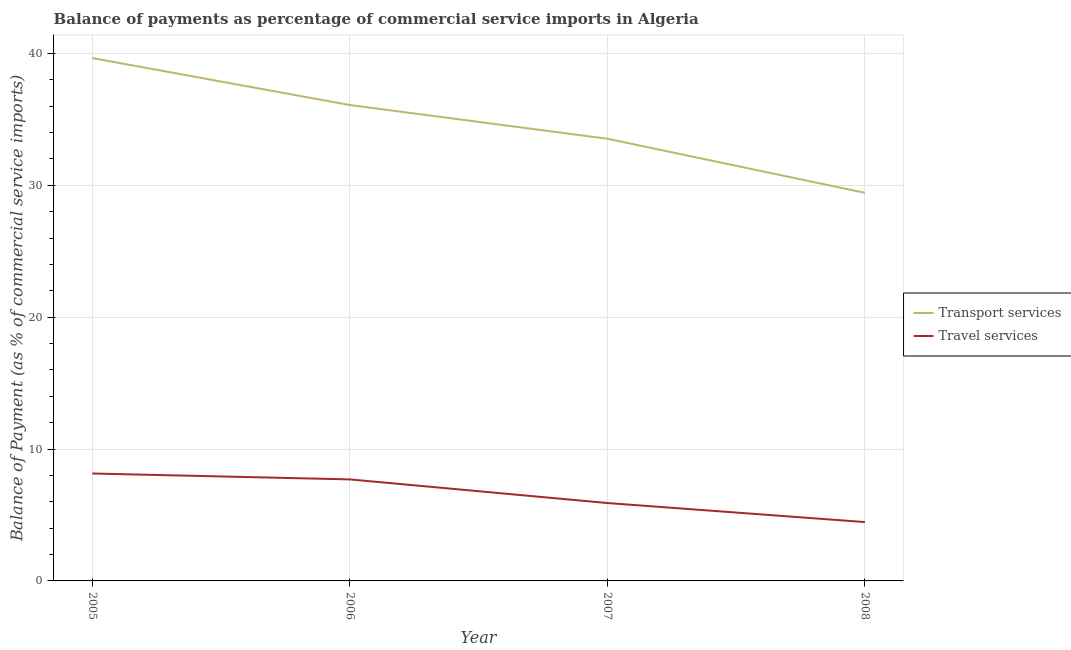Does the line corresponding to balance of payments of travel services intersect with the line corresponding to balance of payments of transport services?
Your response must be concise. No. What is the balance of payments of transport services in 2007?
Make the answer very short. 33.53. Across all years, what is the maximum balance of payments of transport services?
Provide a succinct answer. 39.65. Across all years, what is the minimum balance of payments of transport services?
Keep it short and to the point. 29.43. What is the total balance of payments of travel services in the graph?
Provide a short and direct response. 26.22. What is the difference between the balance of payments of transport services in 2005 and that in 2007?
Your answer should be compact. 6.12. What is the difference between the balance of payments of transport services in 2007 and the balance of payments of travel services in 2008?
Make the answer very short. 29.07. What is the average balance of payments of transport services per year?
Your answer should be very brief. 34.68. In the year 2008, what is the difference between the balance of payments of transport services and balance of payments of travel services?
Your answer should be very brief. 24.97. In how many years, is the balance of payments of travel services greater than 20 %?
Your answer should be very brief. 0. What is the ratio of the balance of payments of travel services in 2005 to that in 2008?
Your answer should be very brief. 1.83. What is the difference between the highest and the second highest balance of payments of transport services?
Provide a short and direct response. 3.56. What is the difference between the highest and the lowest balance of payments of transport services?
Ensure brevity in your answer.  10.22. Does the balance of payments of travel services monotonically increase over the years?
Provide a succinct answer. No. Is the balance of payments of travel services strictly greater than the balance of payments of transport services over the years?
Your response must be concise. No. What is the difference between two consecutive major ticks on the Y-axis?
Provide a short and direct response. 10. Does the graph contain any zero values?
Your answer should be compact. No. How many legend labels are there?
Offer a terse response. 2. What is the title of the graph?
Provide a short and direct response. Balance of payments as percentage of commercial service imports in Algeria. Does "Public credit registry" appear as one of the legend labels in the graph?
Keep it short and to the point. No. What is the label or title of the X-axis?
Ensure brevity in your answer.  Year. What is the label or title of the Y-axis?
Keep it short and to the point. Balance of Payment (as % of commercial service imports). What is the Balance of Payment (as % of commercial service imports) in Transport services in 2005?
Provide a short and direct response. 39.65. What is the Balance of Payment (as % of commercial service imports) in Travel services in 2005?
Give a very brief answer. 8.15. What is the Balance of Payment (as % of commercial service imports) of Transport services in 2006?
Your answer should be very brief. 36.09. What is the Balance of Payment (as % of commercial service imports) in Travel services in 2006?
Your answer should be compact. 7.7. What is the Balance of Payment (as % of commercial service imports) of Transport services in 2007?
Give a very brief answer. 33.53. What is the Balance of Payment (as % of commercial service imports) of Travel services in 2007?
Your response must be concise. 5.91. What is the Balance of Payment (as % of commercial service imports) of Transport services in 2008?
Give a very brief answer. 29.43. What is the Balance of Payment (as % of commercial service imports) in Travel services in 2008?
Make the answer very short. 4.46. Across all years, what is the maximum Balance of Payment (as % of commercial service imports) of Transport services?
Provide a short and direct response. 39.65. Across all years, what is the maximum Balance of Payment (as % of commercial service imports) in Travel services?
Provide a short and direct response. 8.15. Across all years, what is the minimum Balance of Payment (as % of commercial service imports) in Transport services?
Keep it short and to the point. 29.43. Across all years, what is the minimum Balance of Payment (as % of commercial service imports) of Travel services?
Keep it short and to the point. 4.46. What is the total Balance of Payment (as % of commercial service imports) of Transport services in the graph?
Provide a succinct answer. 138.71. What is the total Balance of Payment (as % of commercial service imports) in Travel services in the graph?
Your answer should be compact. 26.22. What is the difference between the Balance of Payment (as % of commercial service imports) of Transport services in 2005 and that in 2006?
Keep it short and to the point. 3.56. What is the difference between the Balance of Payment (as % of commercial service imports) in Travel services in 2005 and that in 2006?
Make the answer very short. 0.45. What is the difference between the Balance of Payment (as % of commercial service imports) in Transport services in 2005 and that in 2007?
Provide a short and direct response. 6.12. What is the difference between the Balance of Payment (as % of commercial service imports) in Travel services in 2005 and that in 2007?
Make the answer very short. 2.24. What is the difference between the Balance of Payment (as % of commercial service imports) of Transport services in 2005 and that in 2008?
Your answer should be very brief. 10.22. What is the difference between the Balance of Payment (as % of commercial service imports) of Travel services in 2005 and that in 2008?
Provide a succinct answer. 3.68. What is the difference between the Balance of Payment (as % of commercial service imports) in Transport services in 2006 and that in 2007?
Your answer should be compact. 2.56. What is the difference between the Balance of Payment (as % of commercial service imports) in Travel services in 2006 and that in 2007?
Ensure brevity in your answer.  1.79. What is the difference between the Balance of Payment (as % of commercial service imports) of Transport services in 2006 and that in 2008?
Your response must be concise. 6.66. What is the difference between the Balance of Payment (as % of commercial service imports) of Travel services in 2006 and that in 2008?
Your response must be concise. 3.24. What is the difference between the Balance of Payment (as % of commercial service imports) of Transport services in 2007 and that in 2008?
Provide a short and direct response. 4.1. What is the difference between the Balance of Payment (as % of commercial service imports) in Travel services in 2007 and that in 2008?
Make the answer very short. 1.44. What is the difference between the Balance of Payment (as % of commercial service imports) in Transport services in 2005 and the Balance of Payment (as % of commercial service imports) in Travel services in 2006?
Provide a succinct answer. 31.95. What is the difference between the Balance of Payment (as % of commercial service imports) in Transport services in 2005 and the Balance of Payment (as % of commercial service imports) in Travel services in 2007?
Ensure brevity in your answer.  33.75. What is the difference between the Balance of Payment (as % of commercial service imports) in Transport services in 2005 and the Balance of Payment (as % of commercial service imports) in Travel services in 2008?
Provide a short and direct response. 35.19. What is the difference between the Balance of Payment (as % of commercial service imports) of Transport services in 2006 and the Balance of Payment (as % of commercial service imports) of Travel services in 2007?
Provide a short and direct response. 30.18. What is the difference between the Balance of Payment (as % of commercial service imports) in Transport services in 2006 and the Balance of Payment (as % of commercial service imports) in Travel services in 2008?
Offer a terse response. 31.63. What is the difference between the Balance of Payment (as % of commercial service imports) in Transport services in 2007 and the Balance of Payment (as % of commercial service imports) in Travel services in 2008?
Offer a very short reply. 29.07. What is the average Balance of Payment (as % of commercial service imports) of Transport services per year?
Keep it short and to the point. 34.68. What is the average Balance of Payment (as % of commercial service imports) in Travel services per year?
Offer a terse response. 6.55. In the year 2005, what is the difference between the Balance of Payment (as % of commercial service imports) in Transport services and Balance of Payment (as % of commercial service imports) in Travel services?
Ensure brevity in your answer.  31.51. In the year 2006, what is the difference between the Balance of Payment (as % of commercial service imports) in Transport services and Balance of Payment (as % of commercial service imports) in Travel services?
Make the answer very short. 28.39. In the year 2007, what is the difference between the Balance of Payment (as % of commercial service imports) in Transport services and Balance of Payment (as % of commercial service imports) in Travel services?
Your response must be concise. 27.63. In the year 2008, what is the difference between the Balance of Payment (as % of commercial service imports) in Transport services and Balance of Payment (as % of commercial service imports) in Travel services?
Give a very brief answer. 24.97. What is the ratio of the Balance of Payment (as % of commercial service imports) of Transport services in 2005 to that in 2006?
Provide a succinct answer. 1.1. What is the ratio of the Balance of Payment (as % of commercial service imports) of Travel services in 2005 to that in 2006?
Your response must be concise. 1.06. What is the ratio of the Balance of Payment (as % of commercial service imports) of Transport services in 2005 to that in 2007?
Give a very brief answer. 1.18. What is the ratio of the Balance of Payment (as % of commercial service imports) in Travel services in 2005 to that in 2007?
Provide a succinct answer. 1.38. What is the ratio of the Balance of Payment (as % of commercial service imports) of Transport services in 2005 to that in 2008?
Provide a succinct answer. 1.35. What is the ratio of the Balance of Payment (as % of commercial service imports) in Travel services in 2005 to that in 2008?
Your answer should be compact. 1.83. What is the ratio of the Balance of Payment (as % of commercial service imports) of Transport services in 2006 to that in 2007?
Make the answer very short. 1.08. What is the ratio of the Balance of Payment (as % of commercial service imports) of Travel services in 2006 to that in 2007?
Provide a succinct answer. 1.3. What is the ratio of the Balance of Payment (as % of commercial service imports) of Transport services in 2006 to that in 2008?
Keep it short and to the point. 1.23. What is the ratio of the Balance of Payment (as % of commercial service imports) of Travel services in 2006 to that in 2008?
Your answer should be compact. 1.73. What is the ratio of the Balance of Payment (as % of commercial service imports) in Transport services in 2007 to that in 2008?
Your answer should be very brief. 1.14. What is the ratio of the Balance of Payment (as % of commercial service imports) of Travel services in 2007 to that in 2008?
Your response must be concise. 1.32. What is the difference between the highest and the second highest Balance of Payment (as % of commercial service imports) in Transport services?
Provide a short and direct response. 3.56. What is the difference between the highest and the second highest Balance of Payment (as % of commercial service imports) in Travel services?
Keep it short and to the point. 0.45. What is the difference between the highest and the lowest Balance of Payment (as % of commercial service imports) in Transport services?
Make the answer very short. 10.22. What is the difference between the highest and the lowest Balance of Payment (as % of commercial service imports) of Travel services?
Your response must be concise. 3.68. 